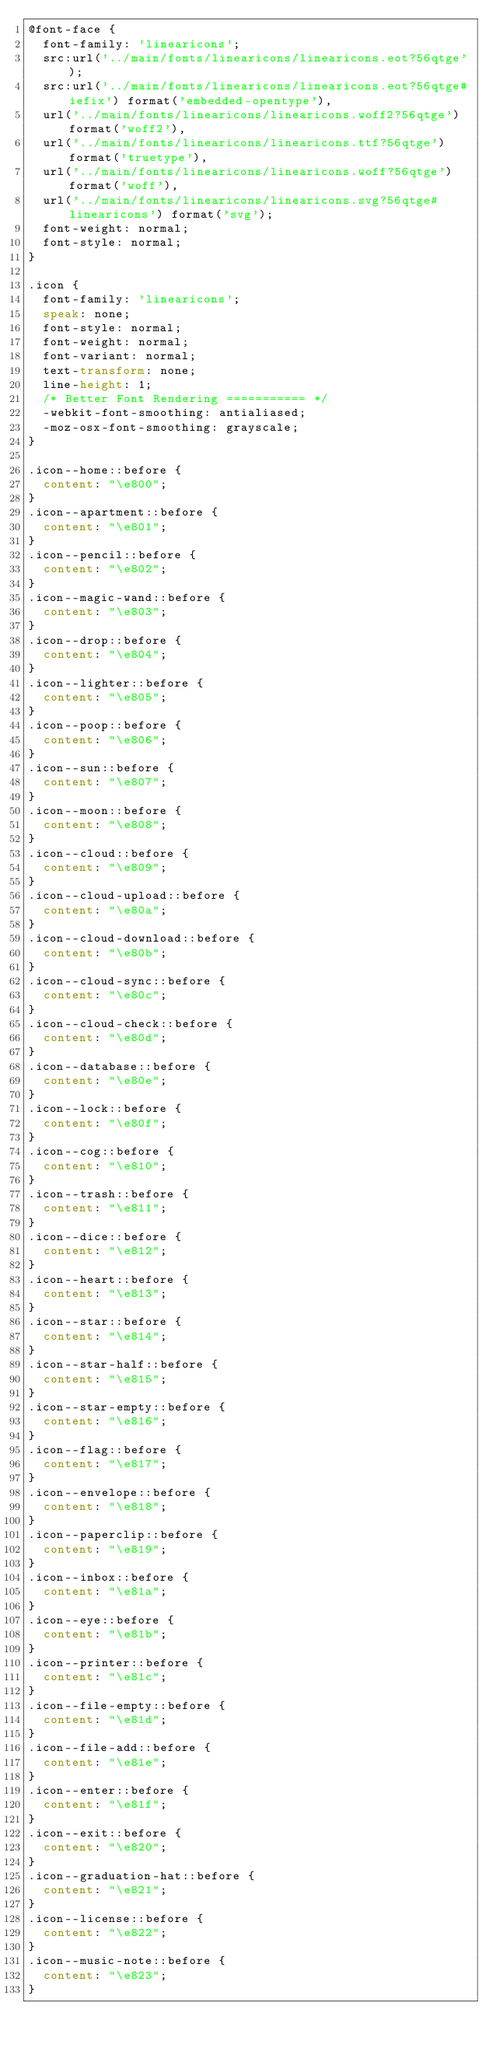Convert code to text. <code><loc_0><loc_0><loc_500><loc_500><_CSS_>@font-face {
  font-family: 'linearicons';
  src:url('../main/fonts/linearicons/linearicons.eot?56qtge');
  src:url('../main/fonts/linearicons/linearicons.eot?56qtge#iefix') format('embedded-opentype'),
  url('../main/fonts/linearicons/linearicons.woff2?56qtge') format('woff2'),
  url('../main/fonts/linearicons/linearicons.ttf?56qtge') format('truetype'),
  url('../main/fonts/linearicons/linearicons.woff?56qtge') format('woff'),
  url('../main/fonts/linearicons/linearicons.svg?56qtge#linearicons') format('svg');
  font-weight: normal;
  font-style: normal;
}

.icon {
  font-family: 'linearicons';
  speak: none;
  font-style: normal;
  font-weight: normal;
  font-variant: normal;
  text-transform: none;
  line-height: 1;
  /* Better Font Rendering =========== */
  -webkit-font-smoothing: antialiased;
  -moz-osx-font-smoothing: grayscale;
}

.icon--home::before {
  content: "\e800";
}
.icon--apartment::before {
  content: "\e801";
}
.icon--pencil::before {
  content: "\e802";
}
.icon--magic-wand::before {
  content: "\e803";
}
.icon--drop::before {
  content: "\e804";
}
.icon--lighter::before {
  content: "\e805";
}
.icon--poop::before {
  content: "\e806";
}
.icon--sun::before {
  content: "\e807";
}
.icon--moon::before {
  content: "\e808";
}
.icon--cloud::before {
  content: "\e809";
}
.icon--cloud-upload::before {
  content: "\e80a";
}
.icon--cloud-download::before {
  content: "\e80b";
}
.icon--cloud-sync::before {
  content: "\e80c";
}
.icon--cloud-check::before {
  content: "\e80d";
}
.icon--database::before {
  content: "\e80e";
}
.icon--lock::before {
  content: "\e80f";
}
.icon--cog::before {
  content: "\e810";
}
.icon--trash::before {
  content: "\e811";
}
.icon--dice::before {
  content: "\e812";
}
.icon--heart::before {
  content: "\e813";
}
.icon--star::before {
  content: "\e814";
}
.icon--star-half::before {
  content: "\e815";
}
.icon--star-empty::before {
  content: "\e816";
}
.icon--flag::before {
  content: "\e817";
}
.icon--envelope::before {
  content: "\e818";
}
.icon--paperclip::before {
  content: "\e819";
}
.icon--inbox::before {
  content: "\e81a";
}
.icon--eye::before {
  content: "\e81b";
}
.icon--printer::before {
  content: "\e81c";
}
.icon--file-empty::before {
  content: "\e81d";
}
.icon--file-add::before {
  content: "\e81e";
}
.icon--enter::before {
  content: "\e81f";
}
.icon--exit::before {
  content: "\e820";
}
.icon--graduation-hat::before {
  content: "\e821";
}
.icon--license::before {
  content: "\e822";
}
.icon--music-note::before {
  content: "\e823";
}</code> 